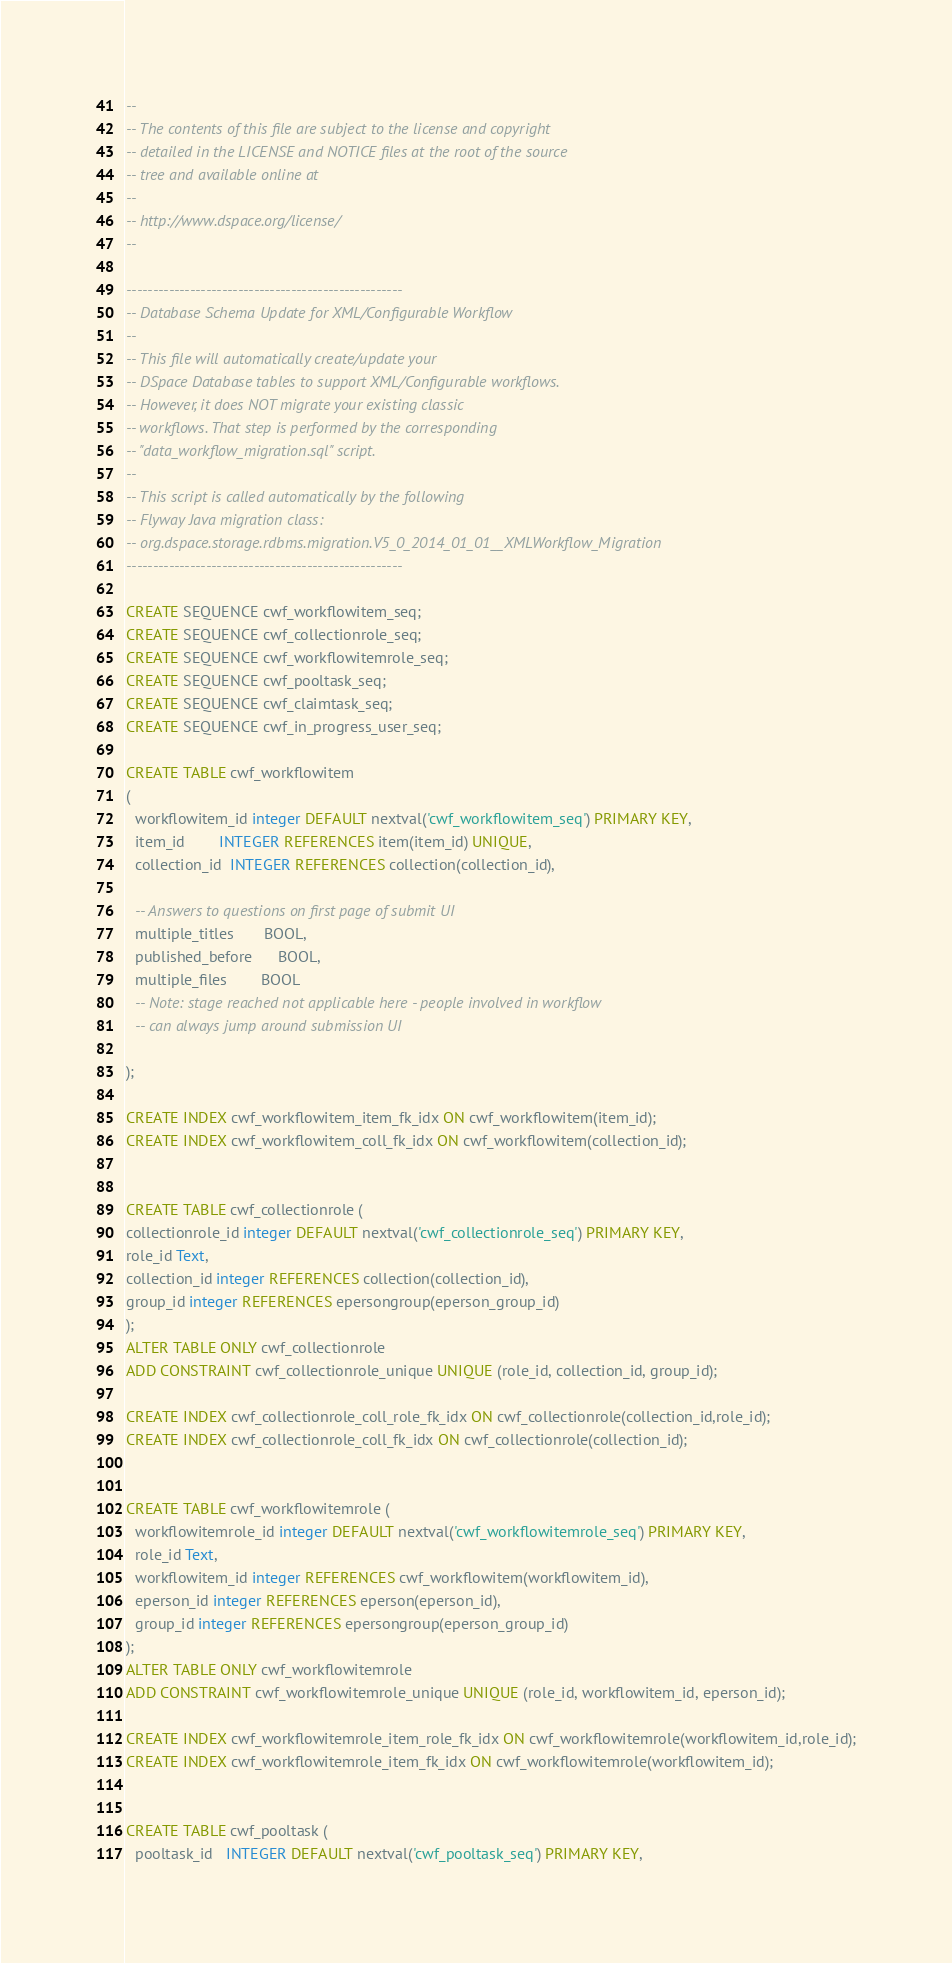<code> <loc_0><loc_0><loc_500><loc_500><_SQL_>--
-- The contents of this file are subject to the license and copyright
-- detailed in the LICENSE and NOTICE files at the root of the source
-- tree and available online at
--
-- http://www.dspace.org/license/
--

----------------------------------------------------
-- Database Schema Update for XML/Configurable Workflow
--
-- This file will automatically create/update your
-- DSpace Database tables to support XML/Configurable workflows.
-- However, it does NOT migrate your existing classic
-- workflows. That step is performed by the corresponding
-- "data_workflow_migration.sql" script.
--
-- This script is called automatically by the following
-- Flyway Java migration class:
-- org.dspace.storage.rdbms.migration.V5_0_2014_01_01__XMLWorkflow_Migration
----------------------------------------------------

CREATE SEQUENCE cwf_workflowitem_seq;
CREATE SEQUENCE cwf_collectionrole_seq;
CREATE SEQUENCE cwf_workflowitemrole_seq;
CREATE SEQUENCE cwf_pooltask_seq;
CREATE SEQUENCE cwf_claimtask_seq;
CREATE SEQUENCE cwf_in_progress_user_seq;

CREATE TABLE cwf_workflowitem
(
  workflowitem_id integer DEFAULT nextval('cwf_workflowitem_seq') PRIMARY KEY,
  item_id        INTEGER REFERENCES item(item_id) UNIQUE,
  collection_id  INTEGER REFERENCES collection(collection_id),

  -- Answers to questions on first page of submit UI
  multiple_titles       BOOL,
  published_before      BOOL,
  multiple_files        BOOL
  -- Note: stage reached not applicable here - people involved in workflow
  -- can always jump around submission UI

);

CREATE INDEX cwf_workflowitem_item_fk_idx ON cwf_workflowitem(item_id);
CREATE INDEX cwf_workflowitem_coll_fk_idx ON cwf_workflowitem(collection_id);


CREATE TABLE cwf_collectionrole (
collectionrole_id integer DEFAULT nextval('cwf_collectionrole_seq') PRIMARY KEY,
role_id Text,
collection_id integer REFERENCES collection(collection_id),
group_id integer REFERENCES epersongroup(eperson_group_id)
);
ALTER TABLE ONLY cwf_collectionrole
ADD CONSTRAINT cwf_collectionrole_unique UNIQUE (role_id, collection_id, group_id);

CREATE INDEX cwf_collectionrole_coll_role_fk_idx ON cwf_collectionrole(collection_id,role_id);
CREATE INDEX cwf_collectionrole_coll_fk_idx ON cwf_collectionrole(collection_id);


CREATE TABLE cwf_workflowitemrole (
  workflowitemrole_id integer DEFAULT nextval('cwf_workflowitemrole_seq') PRIMARY KEY,
  role_id Text,
  workflowitem_id integer REFERENCES cwf_workflowitem(workflowitem_id),
  eperson_id integer REFERENCES eperson(eperson_id),
  group_id integer REFERENCES epersongroup(eperson_group_id)
);
ALTER TABLE ONLY cwf_workflowitemrole
ADD CONSTRAINT cwf_workflowitemrole_unique UNIQUE (role_id, workflowitem_id, eperson_id);

CREATE INDEX cwf_workflowitemrole_item_role_fk_idx ON cwf_workflowitemrole(workflowitem_id,role_id);
CREATE INDEX cwf_workflowitemrole_item_fk_idx ON cwf_workflowitemrole(workflowitem_id);


CREATE TABLE cwf_pooltask (
  pooltask_id   INTEGER DEFAULT nextval('cwf_pooltask_seq') PRIMARY KEY,</code> 